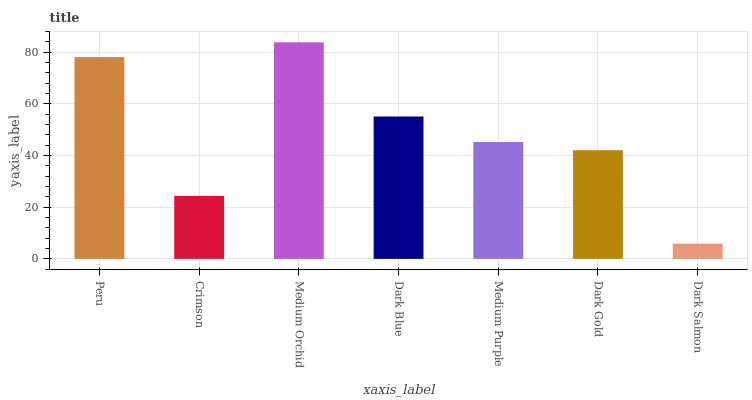Is Dark Salmon the minimum?
Answer yes or no. Yes. Is Medium Orchid the maximum?
Answer yes or no. Yes. Is Crimson the minimum?
Answer yes or no. No. Is Crimson the maximum?
Answer yes or no. No. Is Peru greater than Crimson?
Answer yes or no. Yes. Is Crimson less than Peru?
Answer yes or no. Yes. Is Crimson greater than Peru?
Answer yes or no. No. Is Peru less than Crimson?
Answer yes or no. No. Is Medium Purple the high median?
Answer yes or no. Yes. Is Medium Purple the low median?
Answer yes or no. Yes. Is Medium Orchid the high median?
Answer yes or no. No. Is Dark Blue the low median?
Answer yes or no. No. 